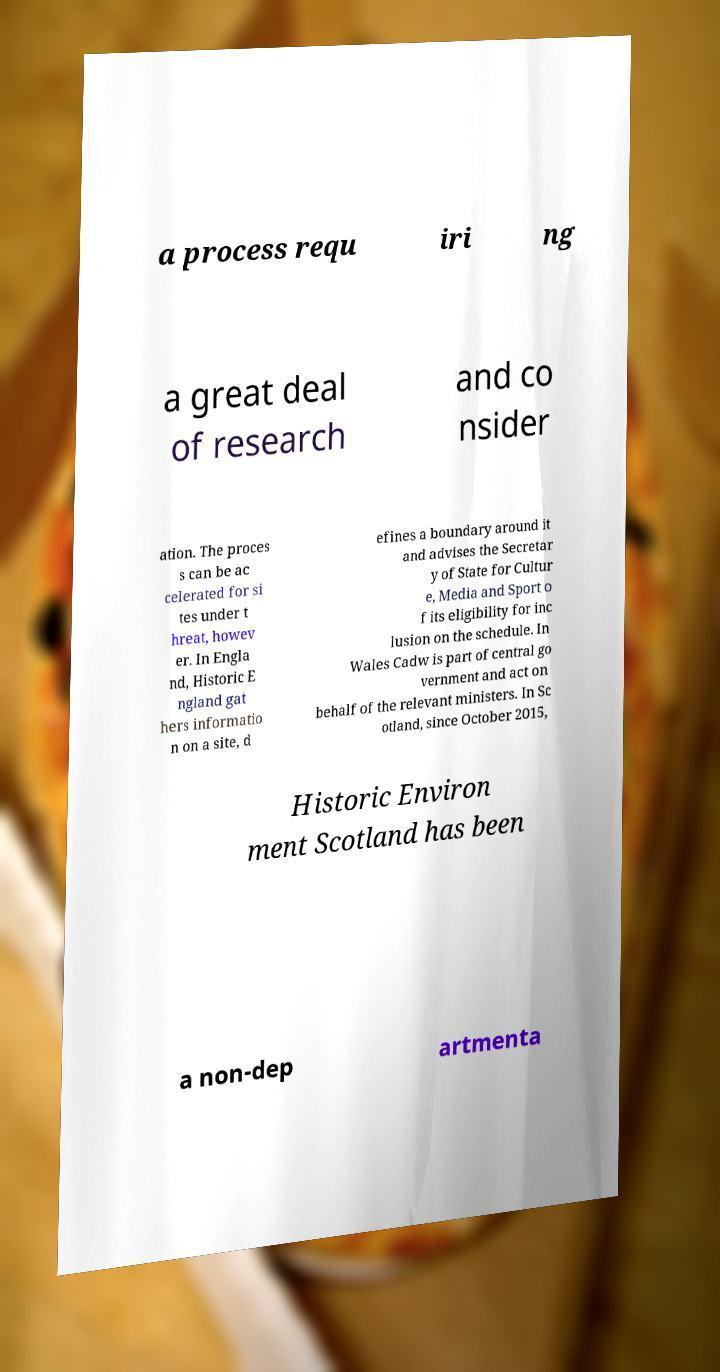For documentation purposes, I need the text within this image transcribed. Could you provide that? a process requ iri ng a great deal of research and co nsider ation. The proces s can be ac celerated for si tes under t hreat, howev er. In Engla nd, Historic E ngland gat hers informatio n on a site, d efines a boundary around it and advises the Secretar y of State for Cultur e, Media and Sport o f its eligibility for inc lusion on the schedule. In Wales Cadw is part of central go vernment and act on behalf of the relevant ministers. In Sc otland, since October 2015, Historic Environ ment Scotland has been a non-dep artmenta 